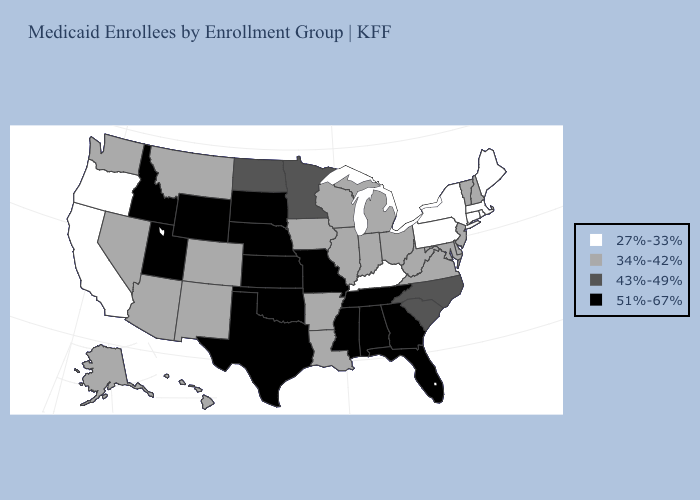What is the value of Idaho?
Write a very short answer. 51%-67%. What is the value of Minnesota?
Write a very short answer. 43%-49%. Name the states that have a value in the range 43%-49%?
Concise answer only. Minnesota, North Carolina, North Dakota, South Carolina. Name the states that have a value in the range 43%-49%?
Give a very brief answer. Minnesota, North Carolina, North Dakota, South Carolina. Among the states that border Massachusetts , which have the lowest value?
Short answer required. Connecticut, New York, Rhode Island. Does Wisconsin have a higher value than Oklahoma?
Keep it brief. No. Among the states that border North Dakota , which have the highest value?
Short answer required. South Dakota. Name the states that have a value in the range 51%-67%?
Give a very brief answer. Alabama, Florida, Georgia, Idaho, Kansas, Mississippi, Missouri, Nebraska, Oklahoma, South Dakota, Tennessee, Texas, Utah, Wyoming. Does the first symbol in the legend represent the smallest category?
Write a very short answer. Yes. Does Vermont have the highest value in the Northeast?
Give a very brief answer. Yes. Name the states that have a value in the range 34%-42%?
Write a very short answer. Alaska, Arizona, Arkansas, Colorado, Delaware, Hawaii, Illinois, Indiana, Iowa, Louisiana, Maryland, Michigan, Montana, Nevada, New Hampshire, New Jersey, New Mexico, Ohio, Vermont, Virginia, Washington, West Virginia, Wisconsin. Name the states that have a value in the range 51%-67%?
Keep it brief. Alabama, Florida, Georgia, Idaho, Kansas, Mississippi, Missouri, Nebraska, Oklahoma, South Dakota, Tennessee, Texas, Utah, Wyoming. Does Iowa have the same value as Oklahoma?
Keep it brief. No. Among the states that border North Carolina , which have the highest value?
Quick response, please. Georgia, Tennessee. 